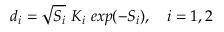Convert formula to latex. <formula><loc_0><loc_0><loc_500><loc_500>d _ { i } = \sqrt { S _ { i } } \ K _ { i } \ e x p ( - S _ { i } ) , \quad i = 1 , 2</formula> 